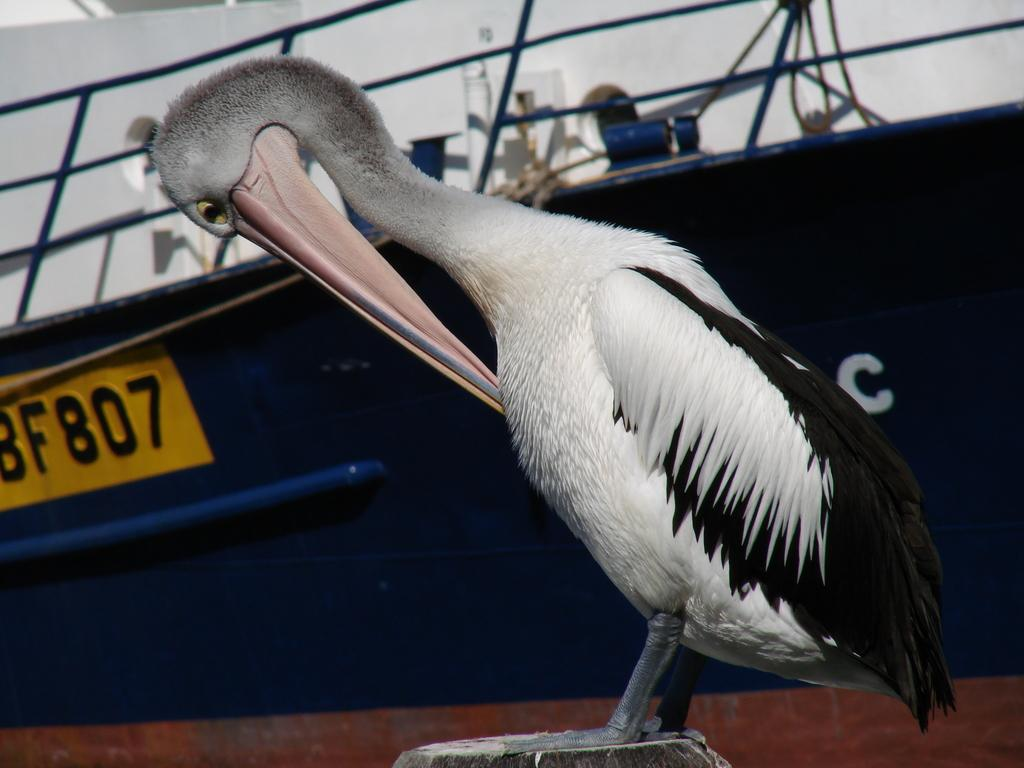What type of animal can be seen in the image? There is a bird in the image. What can be seen in the background of the image? There is a ship in the background of the image. What type of furniture is present in the image? There is no furniture present in the image; it features a bird and a ship in the background. What is the bird holding in the middle of the image? The bird is not holding anything in the image, and there is no object in the middle of the image. 